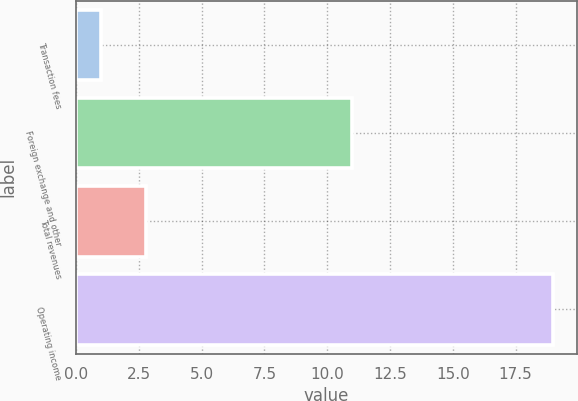Convert chart. <chart><loc_0><loc_0><loc_500><loc_500><bar_chart><fcel>Transaction fees<fcel>Foreign exchange and other<fcel>Total revenues<fcel>Operating income<nl><fcel>1<fcel>11<fcel>2.8<fcel>19<nl></chart> 